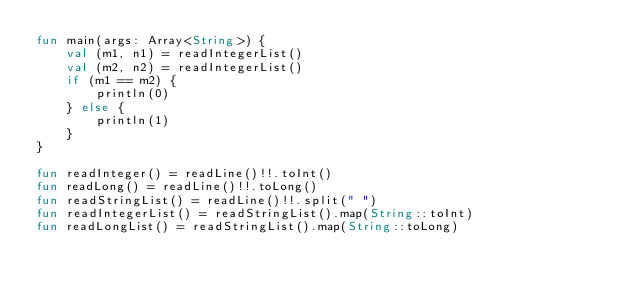Convert code to text. <code><loc_0><loc_0><loc_500><loc_500><_Kotlin_>fun main(args: Array<String>) {
    val (m1, n1) = readIntegerList()
    val (m2, n2) = readIntegerList()
    if (m1 == m2) {
        println(0)
    } else {
        println(1)
    }
}

fun readInteger() = readLine()!!.toInt()
fun readLong() = readLine()!!.toLong()
fun readStringList() = readLine()!!.split(" ")
fun readIntegerList() = readStringList().map(String::toInt)
fun readLongList() = readStringList().map(String::toLong)
</code> 